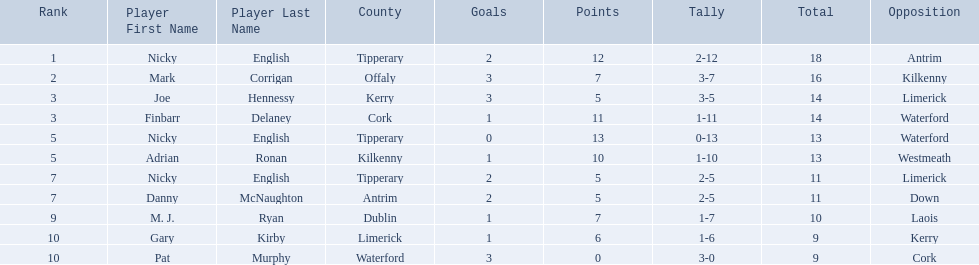What numbers are in the total column? 18, 16, 14, 14, 13, 13, 11, 11, 10, 9, 9. What row has the number 10 in the total column? 9, M. J. Ryan, Dublin, 1-7, 10, Laois. What name is in the player column for this row? M. J. Ryan. 